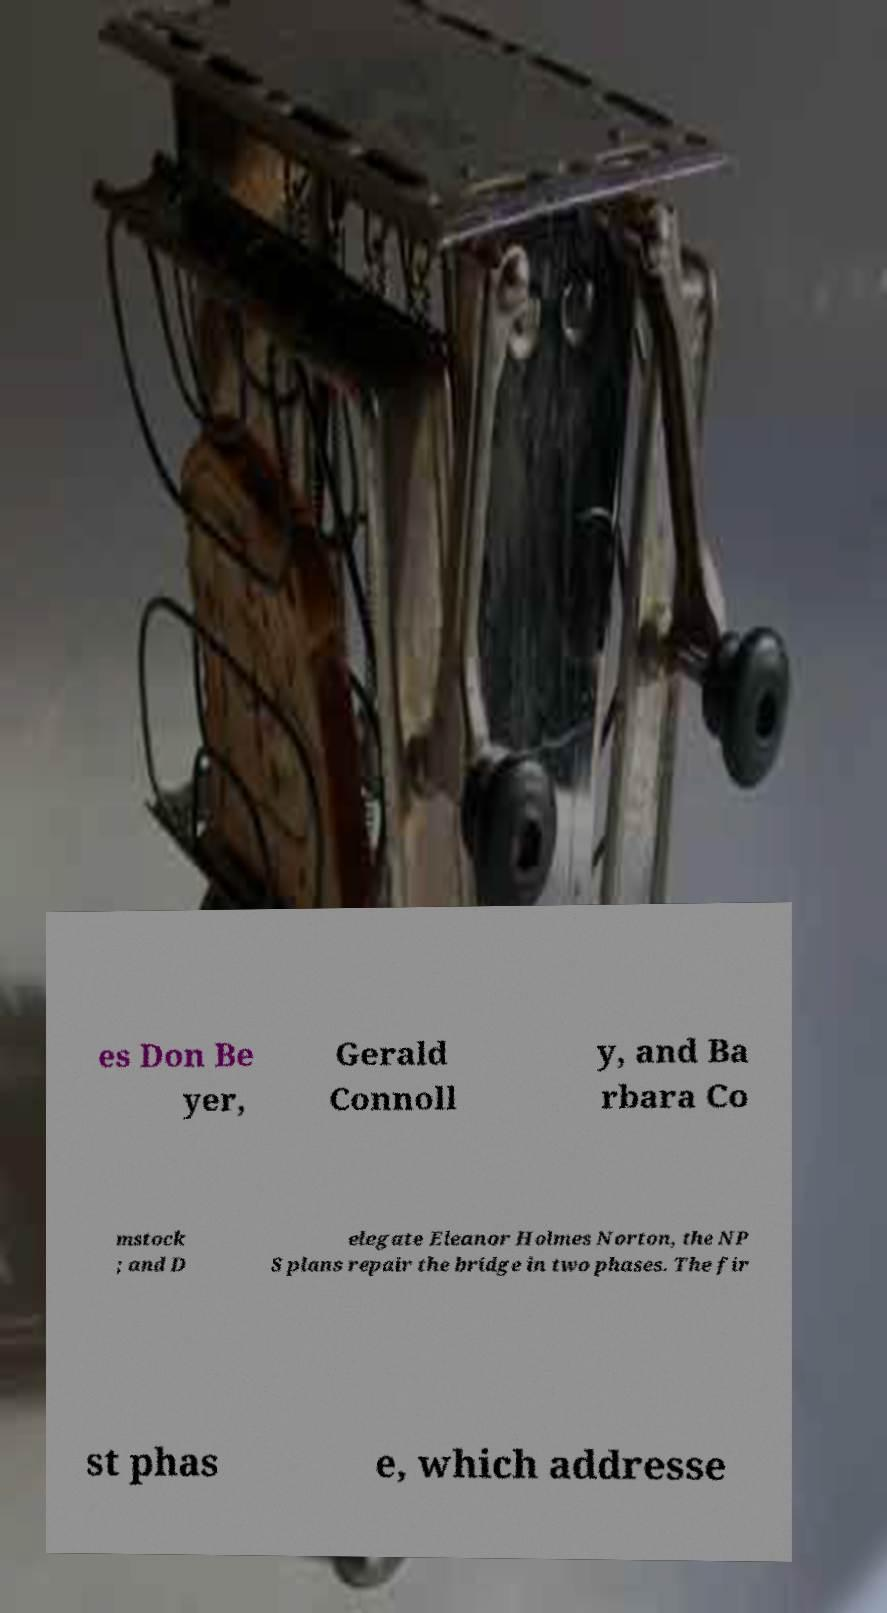Can you read and provide the text displayed in the image?This photo seems to have some interesting text. Can you extract and type it out for me? es Don Be yer, Gerald Connoll y, and Ba rbara Co mstock ; and D elegate Eleanor Holmes Norton, the NP S plans repair the bridge in two phases. The fir st phas e, which addresse 